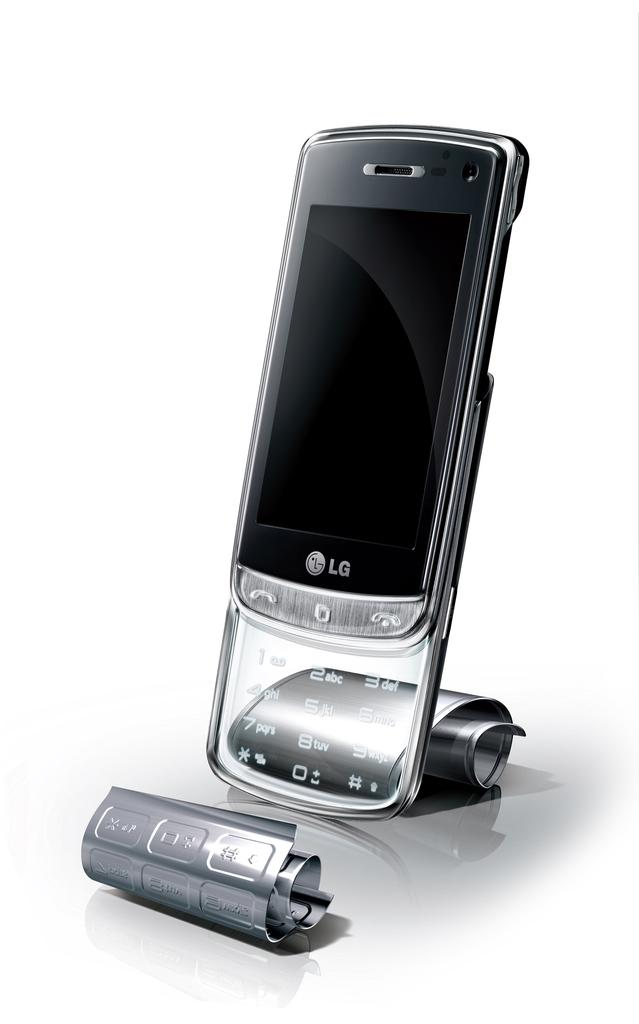Provide a one-sentence caption for the provided image. A silver LG cellphone with no display propped up vertically. 